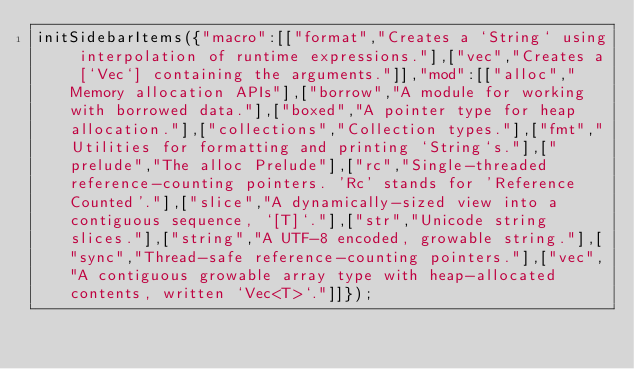Convert code to text. <code><loc_0><loc_0><loc_500><loc_500><_JavaScript_>initSidebarItems({"macro":[["format","Creates a `String` using interpolation of runtime expressions."],["vec","Creates a [`Vec`] containing the arguments."]],"mod":[["alloc","Memory allocation APIs"],["borrow","A module for working with borrowed data."],["boxed","A pointer type for heap allocation."],["collections","Collection types."],["fmt","Utilities for formatting and printing `String`s."],["prelude","The alloc Prelude"],["rc","Single-threaded reference-counting pointers. 'Rc' stands for 'Reference Counted'."],["slice","A dynamically-sized view into a contiguous sequence, `[T]`."],["str","Unicode string slices."],["string","A UTF-8 encoded, growable string."],["sync","Thread-safe reference-counting pointers."],["vec","A contiguous growable array type with heap-allocated contents, written `Vec<T>`."]]});</code> 